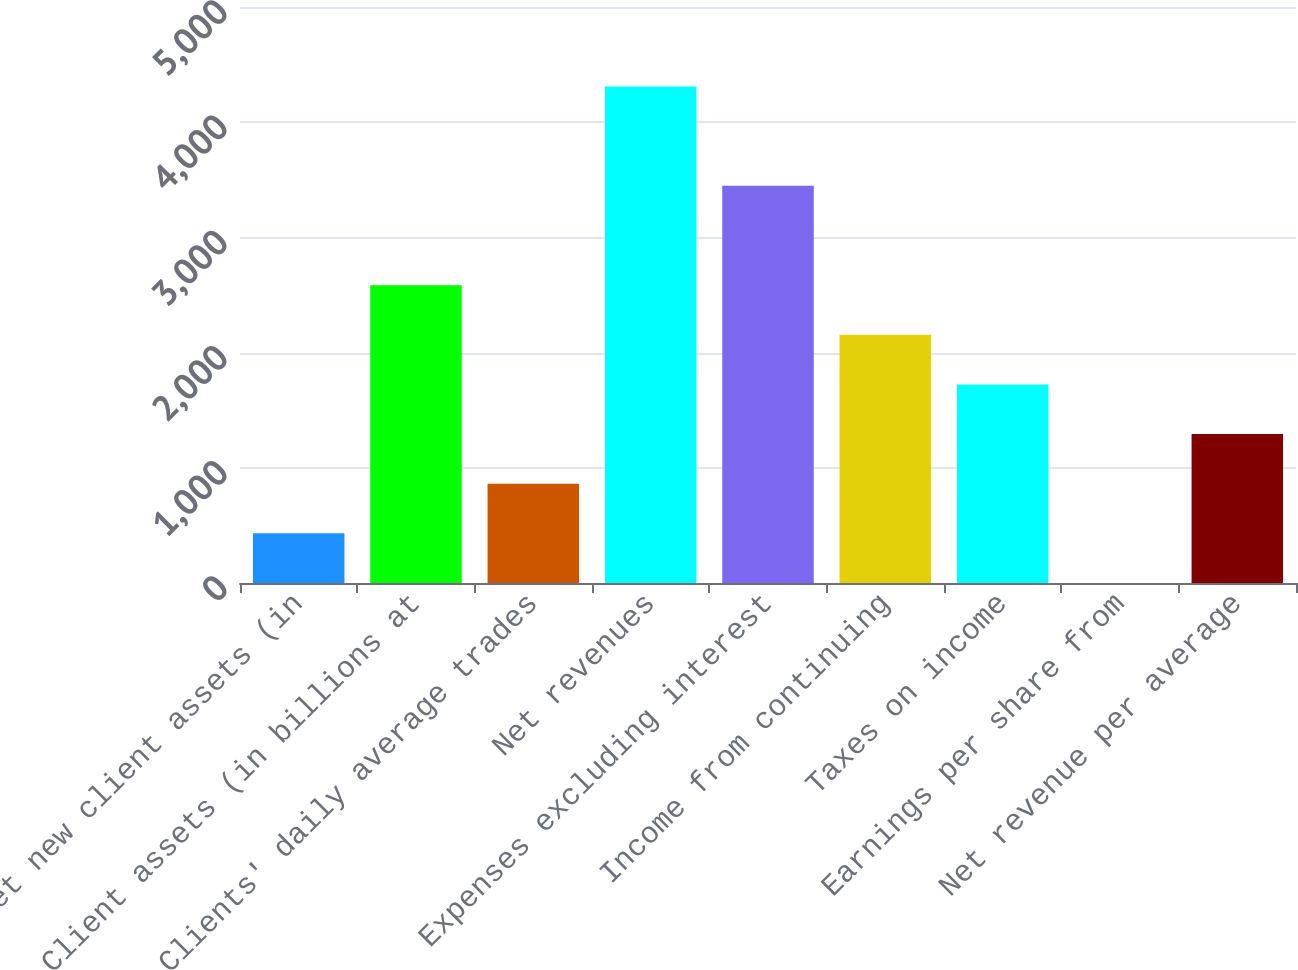Convert chart to OTSL. <chart><loc_0><loc_0><loc_500><loc_500><bar_chart><fcel>Net new client assets (in<fcel>Client assets (in billions at<fcel>Clients' daily average trades<fcel>Net revenues<fcel>Expenses excluding interest<fcel>Income from continuing<fcel>Taxes on income<fcel>Earnings per share from<fcel>Net revenue per average<nl><fcel>431.52<fcel>2585.67<fcel>862.35<fcel>4309<fcel>3447.33<fcel>2154.84<fcel>1724.01<fcel>0.69<fcel>1293.18<nl></chart> 